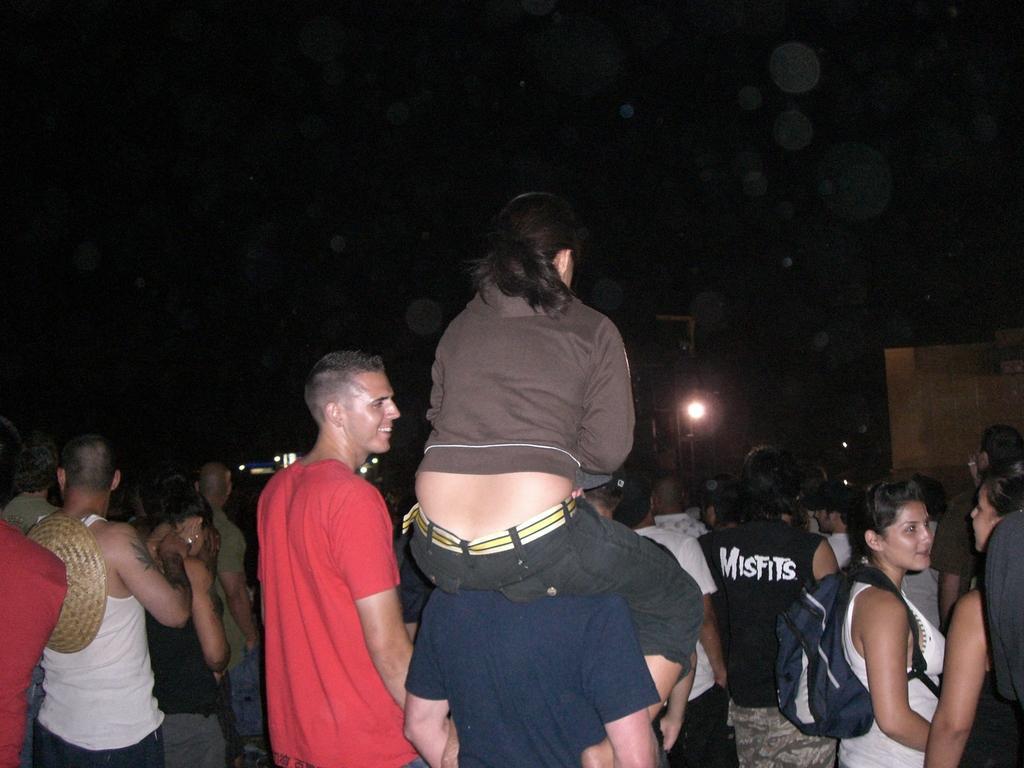In one or two sentences, can you explain what this image depicts? In the center of the image we can see woman sitting on a person's neck. In the background there are group of persons standing on the road and light. 